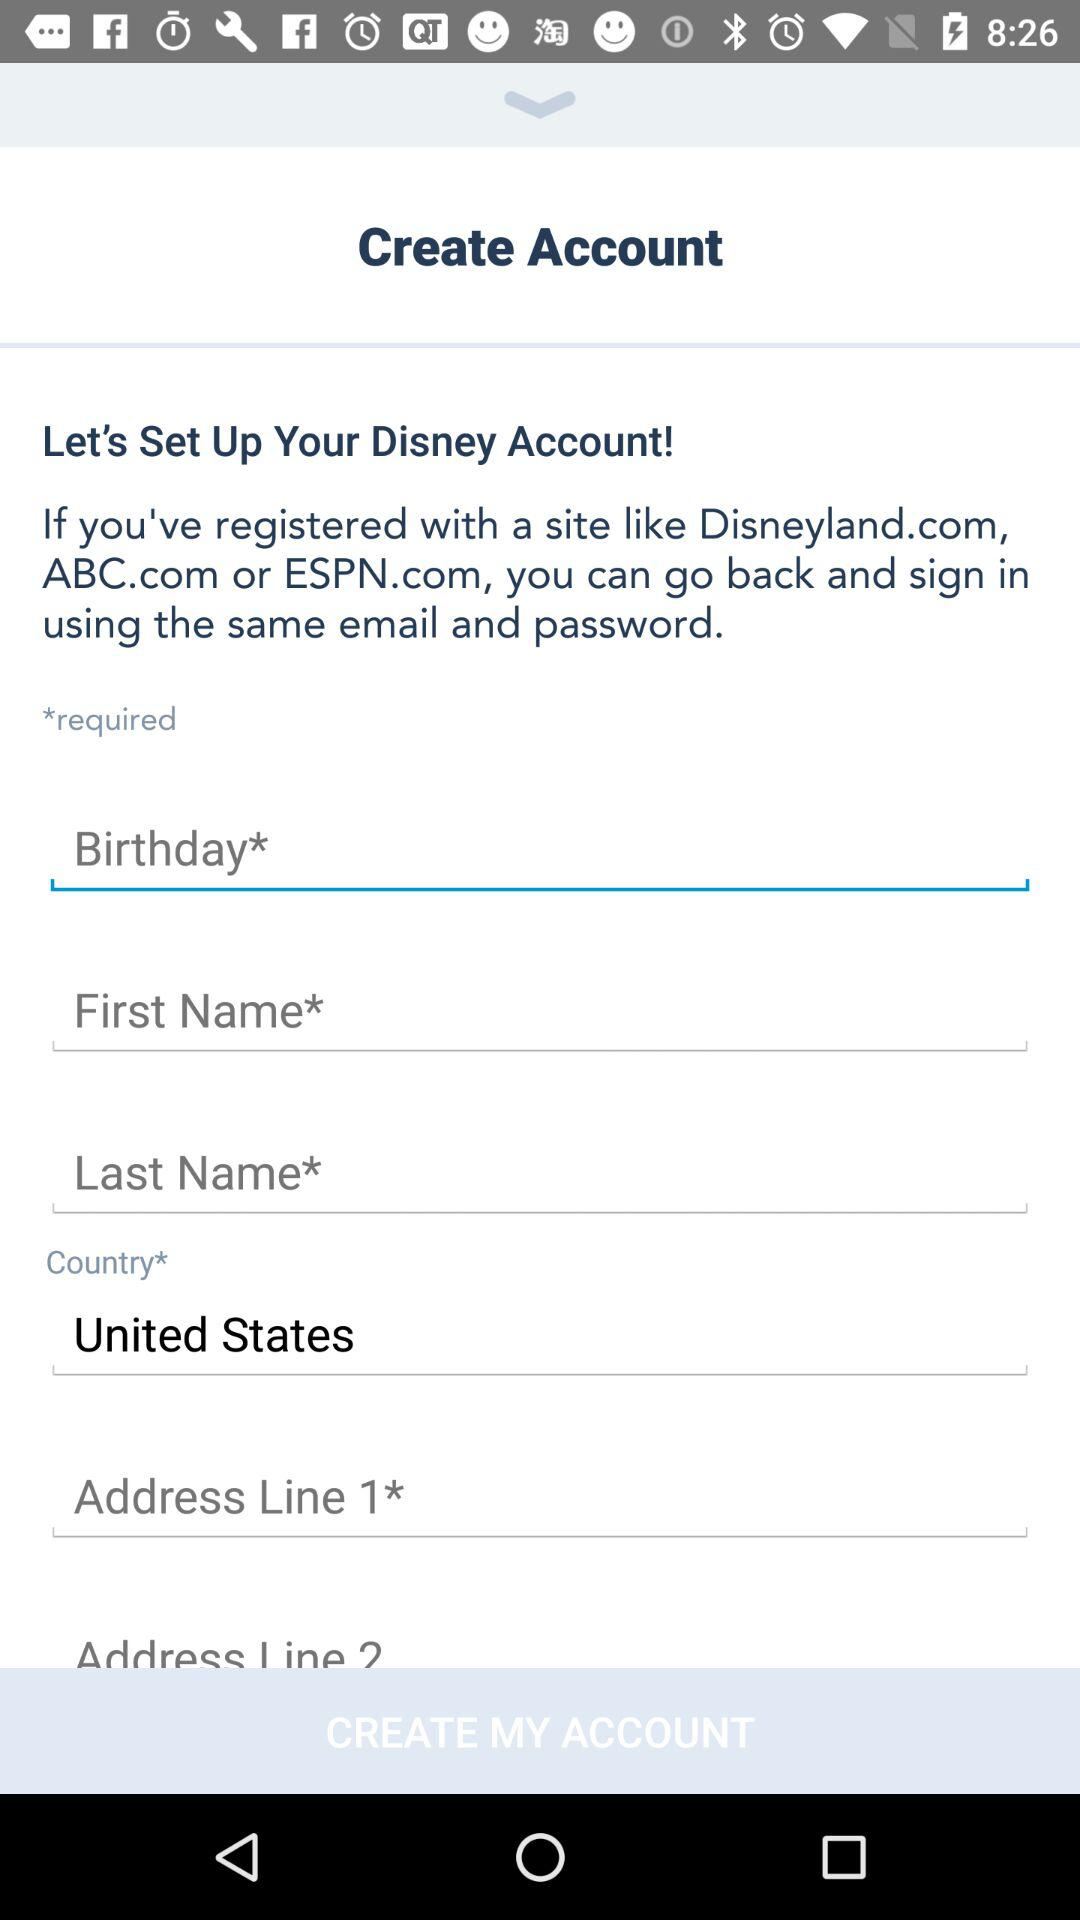Can you explain the purpose of an 'Address Line 2' field in web forms? Certainly! The 'Address Line 2' field is often used to provide additional address information that does not fit in the main address field. It can be used for apartment or suite numbers, building names, or any other details that might be necessary to ensure the address is complete and deliveries can be made accurately. 